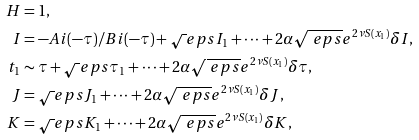<formula> <loc_0><loc_0><loc_500><loc_500>H & = 1 , \\ I & = - A i ( - \tau ) / B i ( - \tau ) + \sqrt { \ } e p s I _ { 1 } + \dots + 2 \alpha \sqrt { \ e p s } e ^ { 2 \nu S ( x _ { 1 } ) } \delta I , \\ t _ { 1 } & \sim \tau + \sqrt { \ } e p s \tau _ { 1 } + \dots + 2 \alpha \sqrt { \ e p s } e ^ { 2 \nu S ( x _ { 1 } ) } \delta \tau , \\ J & = \sqrt { \ } e p s J _ { 1 } + \dots + 2 \alpha \sqrt { \ e p s } e ^ { 2 \nu S ( x _ { 1 } ) } \delta J , \\ K & = \sqrt { \ } e p s K _ { 1 } + \dots + 2 \alpha \sqrt { \ e p s } e ^ { 2 \nu S ( x _ { 1 } ) } \delta K ,</formula> 